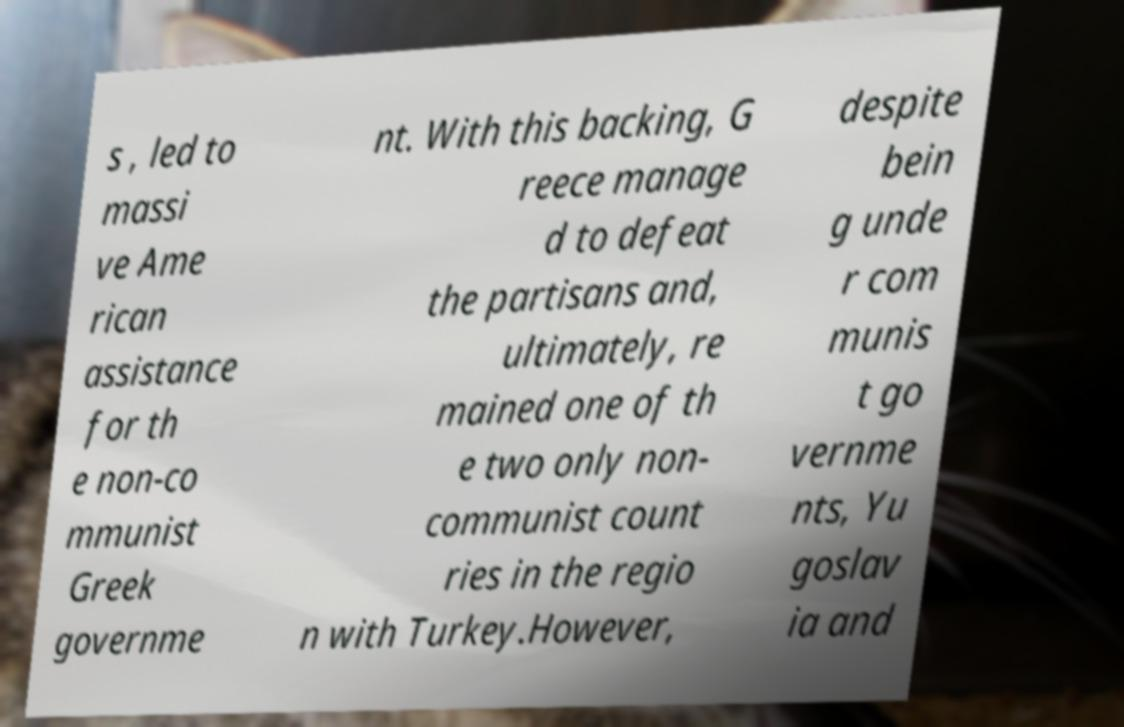What messages or text are displayed in this image? I need them in a readable, typed format. s , led to massi ve Ame rican assistance for th e non-co mmunist Greek governme nt. With this backing, G reece manage d to defeat the partisans and, ultimately, re mained one of th e two only non- communist count ries in the regio n with Turkey.However, despite bein g unde r com munis t go vernme nts, Yu goslav ia and 